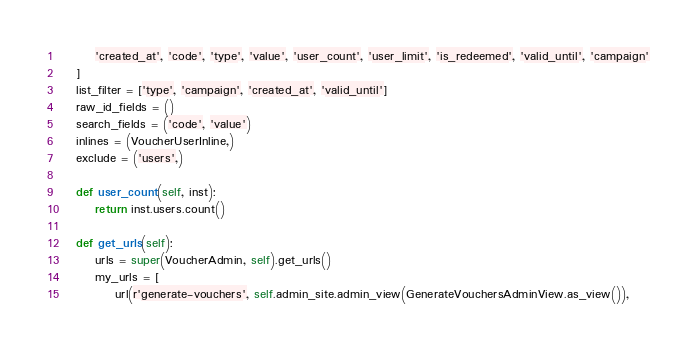<code> <loc_0><loc_0><loc_500><loc_500><_Python_>        'created_at', 'code', 'type', 'value', 'user_count', 'user_limit', 'is_redeemed', 'valid_until', 'campaign'
    ]
    list_filter = ['type', 'campaign', 'created_at', 'valid_until']
    raw_id_fields = ()
    search_fields = ('code', 'value')
    inlines = (VoucherUserInline,)
    exclude = ('users',)

    def user_count(self, inst):
        return inst.users.count()

    def get_urls(self):
        urls = super(VoucherAdmin, self).get_urls()
        my_urls = [
            url(r'generate-vouchers', self.admin_site.admin_view(GenerateVouchersAdminView.as_view()),</code> 